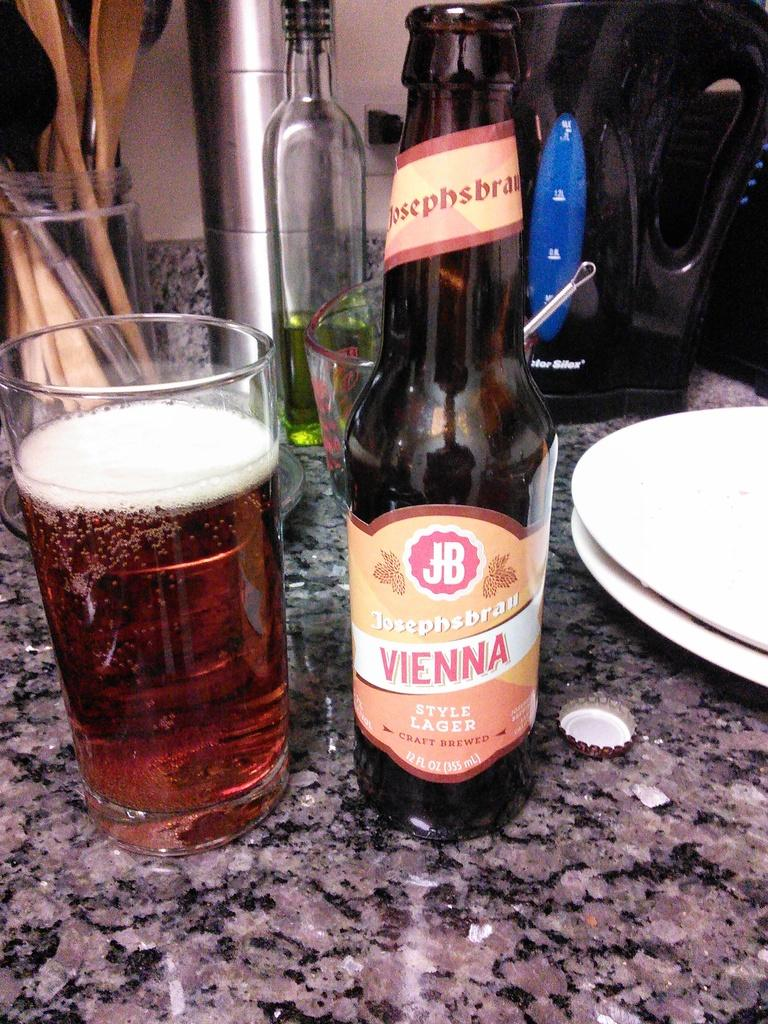<image>
Give a short and clear explanation of the subsequent image. a bottle of Josephsbrau VIENNA Style Lager beer with a glass of the beer next to it. 